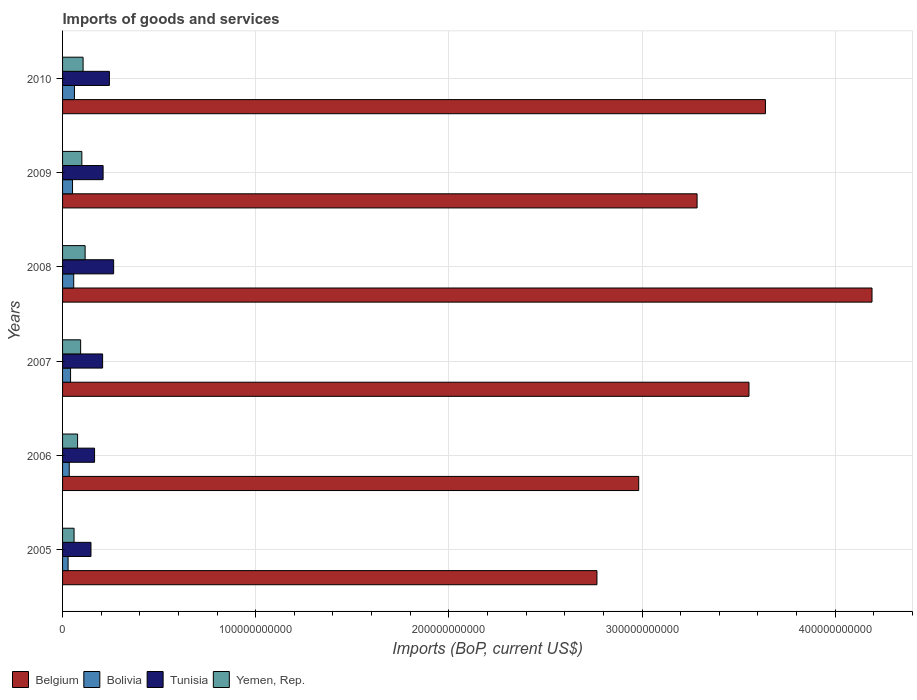How many bars are there on the 1st tick from the top?
Your response must be concise. 4. What is the label of the 3rd group of bars from the top?
Provide a short and direct response. 2008. In how many cases, is the number of bars for a given year not equal to the number of legend labels?
Your response must be concise. 0. What is the amount spent on imports in Tunisia in 2007?
Make the answer very short. 2.07e+1. Across all years, what is the maximum amount spent on imports in Tunisia?
Give a very brief answer. 2.64e+1. Across all years, what is the minimum amount spent on imports in Yemen, Rep.?
Keep it short and to the point. 5.95e+09. In which year was the amount spent on imports in Bolivia maximum?
Your response must be concise. 2010. In which year was the amount spent on imports in Bolivia minimum?
Keep it short and to the point. 2005. What is the total amount spent on imports in Belgium in the graph?
Offer a very short reply. 2.04e+12. What is the difference between the amount spent on imports in Belgium in 2005 and that in 2009?
Your answer should be compact. -5.18e+1. What is the difference between the amount spent on imports in Bolivia in 2010 and the amount spent on imports in Yemen, Rep. in 2008?
Your answer should be compact. -5.53e+09. What is the average amount spent on imports in Yemen, Rep. per year?
Provide a succinct answer. 9.23e+09. In the year 2006, what is the difference between the amount spent on imports in Bolivia and amount spent on imports in Belgium?
Make the answer very short. -2.95e+11. What is the ratio of the amount spent on imports in Yemen, Rep. in 2006 to that in 2009?
Ensure brevity in your answer.  0.78. Is the amount spent on imports in Belgium in 2007 less than that in 2010?
Your answer should be very brief. Yes. Is the difference between the amount spent on imports in Bolivia in 2008 and 2009 greater than the difference between the amount spent on imports in Belgium in 2008 and 2009?
Your answer should be very brief. No. What is the difference between the highest and the second highest amount spent on imports in Bolivia?
Your response must be concise. 3.77e+08. What is the difference between the highest and the lowest amount spent on imports in Tunisia?
Your response must be concise. 1.17e+1. Is it the case that in every year, the sum of the amount spent on imports in Yemen, Rep. and amount spent on imports in Belgium is greater than the sum of amount spent on imports in Tunisia and amount spent on imports in Bolivia?
Your answer should be compact. No. What does the 3rd bar from the bottom in 2008 represents?
Your answer should be compact. Tunisia. Is it the case that in every year, the sum of the amount spent on imports in Belgium and amount spent on imports in Tunisia is greater than the amount spent on imports in Yemen, Rep.?
Give a very brief answer. Yes. How many bars are there?
Your answer should be very brief. 24. Are all the bars in the graph horizontal?
Your answer should be compact. Yes. How many years are there in the graph?
Give a very brief answer. 6. What is the difference between two consecutive major ticks on the X-axis?
Your answer should be very brief. 1.00e+11. Are the values on the major ticks of X-axis written in scientific E-notation?
Provide a short and direct response. No. Does the graph contain any zero values?
Provide a short and direct response. No. Does the graph contain grids?
Provide a succinct answer. Yes. How are the legend labels stacked?
Your answer should be compact. Horizontal. What is the title of the graph?
Offer a terse response. Imports of goods and services. Does "Kosovo" appear as one of the legend labels in the graph?
Give a very brief answer. No. What is the label or title of the X-axis?
Offer a very short reply. Imports (BoP, current US$). What is the Imports (BoP, current US$) of Belgium in 2005?
Give a very brief answer. 2.77e+11. What is the Imports (BoP, current US$) in Bolivia in 2005?
Ensure brevity in your answer.  2.86e+09. What is the Imports (BoP, current US$) of Tunisia in 2005?
Provide a short and direct response. 1.47e+1. What is the Imports (BoP, current US$) in Yemen, Rep. in 2005?
Provide a succinct answer. 5.95e+09. What is the Imports (BoP, current US$) in Belgium in 2006?
Your answer should be very brief. 2.98e+11. What is the Imports (BoP, current US$) in Bolivia in 2006?
Offer a terse response. 3.46e+09. What is the Imports (BoP, current US$) of Tunisia in 2006?
Your response must be concise. 1.66e+1. What is the Imports (BoP, current US$) in Yemen, Rep. in 2006?
Provide a short and direct response. 7.78e+09. What is the Imports (BoP, current US$) of Belgium in 2007?
Provide a short and direct response. 3.55e+11. What is the Imports (BoP, current US$) of Bolivia in 2007?
Keep it short and to the point. 4.14e+09. What is the Imports (BoP, current US$) in Tunisia in 2007?
Ensure brevity in your answer.  2.07e+1. What is the Imports (BoP, current US$) of Yemen, Rep. in 2007?
Your answer should be compact. 9.36e+09. What is the Imports (BoP, current US$) of Belgium in 2008?
Keep it short and to the point. 4.19e+11. What is the Imports (BoP, current US$) in Bolivia in 2008?
Give a very brief answer. 5.78e+09. What is the Imports (BoP, current US$) of Tunisia in 2008?
Your answer should be compact. 2.64e+1. What is the Imports (BoP, current US$) of Yemen, Rep. in 2008?
Your response must be concise. 1.17e+1. What is the Imports (BoP, current US$) of Belgium in 2009?
Ensure brevity in your answer.  3.29e+11. What is the Imports (BoP, current US$) in Bolivia in 2009?
Offer a very short reply. 5.16e+09. What is the Imports (BoP, current US$) of Tunisia in 2009?
Provide a succinct answer. 2.10e+1. What is the Imports (BoP, current US$) of Yemen, Rep. in 2009?
Provide a succinct answer. 9.99e+09. What is the Imports (BoP, current US$) in Belgium in 2010?
Give a very brief answer. 3.64e+11. What is the Imports (BoP, current US$) in Bolivia in 2010?
Provide a succinct answer. 6.16e+09. What is the Imports (BoP, current US$) of Tunisia in 2010?
Offer a very short reply. 2.42e+1. What is the Imports (BoP, current US$) of Yemen, Rep. in 2010?
Ensure brevity in your answer.  1.06e+1. Across all years, what is the maximum Imports (BoP, current US$) of Belgium?
Provide a short and direct response. 4.19e+11. Across all years, what is the maximum Imports (BoP, current US$) of Bolivia?
Your answer should be compact. 6.16e+09. Across all years, what is the maximum Imports (BoP, current US$) in Tunisia?
Keep it short and to the point. 2.64e+1. Across all years, what is the maximum Imports (BoP, current US$) in Yemen, Rep.?
Offer a very short reply. 1.17e+1. Across all years, what is the minimum Imports (BoP, current US$) of Belgium?
Make the answer very short. 2.77e+11. Across all years, what is the minimum Imports (BoP, current US$) of Bolivia?
Ensure brevity in your answer.  2.86e+09. Across all years, what is the minimum Imports (BoP, current US$) in Tunisia?
Ensure brevity in your answer.  1.47e+1. Across all years, what is the minimum Imports (BoP, current US$) of Yemen, Rep.?
Your answer should be very brief. 5.95e+09. What is the total Imports (BoP, current US$) in Belgium in the graph?
Offer a terse response. 2.04e+12. What is the total Imports (BoP, current US$) of Bolivia in the graph?
Offer a terse response. 2.76e+1. What is the total Imports (BoP, current US$) of Tunisia in the graph?
Provide a succinct answer. 1.24e+11. What is the total Imports (BoP, current US$) in Yemen, Rep. in the graph?
Your answer should be compact. 5.54e+1. What is the difference between the Imports (BoP, current US$) of Belgium in 2005 and that in 2006?
Provide a succinct answer. -2.16e+1. What is the difference between the Imports (BoP, current US$) in Bolivia in 2005 and that in 2006?
Offer a very short reply. -5.92e+08. What is the difference between the Imports (BoP, current US$) in Tunisia in 2005 and that in 2006?
Your response must be concise. -1.86e+09. What is the difference between the Imports (BoP, current US$) of Yemen, Rep. in 2005 and that in 2006?
Offer a very short reply. -1.83e+09. What is the difference between the Imports (BoP, current US$) of Belgium in 2005 and that in 2007?
Provide a short and direct response. -7.87e+1. What is the difference between the Imports (BoP, current US$) of Bolivia in 2005 and that in 2007?
Your answer should be very brief. -1.28e+09. What is the difference between the Imports (BoP, current US$) of Tunisia in 2005 and that in 2007?
Give a very brief answer. -6.03e+09. What is the difference between the Imports (BoP, current US$) of Yemen, Rep. in 2005 and that in 2007?
Offer a very short reply. -3.40e+09. What is the difference between the Imports (BoP, current US$) in Belgium in 2005 and that in 2008?
Provide a succinct answer. -1.42e+11. What is the difference between the Imports (BoP, current US$) in Bolivia in 2005 and that in 2008?
Ensure brevity in your answer.  -2.91e+09. What is the difference between the Imports (BoP, current US$) in Tunisia in 2005 and that in 2008?
Your answer should be very brief. -1.17e+1. What is the difference between the Imports (BoP, current US$) in Yemen, Rep. in 2005 and that in 2008?
Give a very brief answer. -5.73e+09. What is the difference between the Imports (BoP, current US$) of Belgium in 2005 and that in 2009?
Make the answer very short. -5.18e+1. What is the difference between the Imports (BoP, current US$) of Bolivia in 2005 and that in 2009?
Keep it short and to the point. -2.29e+09. What is the difference between the Imports (BoP, current US$) in Tunisia in 2005 and that in 2009?
Your answer should be very brief. -6.29e+09. What is the difference between the Imports (BoP, current US$) of Yemen, Rep. in 2005 and that in 2009?
Keep it short and to the point. -4.03e+09. What is the difference between the Imports (BoP, current US$) of Belgium in 2005 and that in 2010?
Your answer should be very brief. -8.72e+1. What is the difference between the Imports (BoP, current US$) of Bolivia in 2005 and that in 2010?
Offer a terse response. -3.29e+09. What is the difference between the Imports (BoP, current US$) in Tunisia in 2005 and that in 2010?
Ensure brevity in your answer.  -9.54e+09. What is the difference between the Imports (BoP, current US$) in Yemen, Rep. in 2005 and that in 2010?
Provide a short and direct response. -4.67e+09. What is the difference between the Imports (BoP, current US$) of Belgium in 2006 and that in 2007?
Offer a terse response. -5.71e+1. What is the difference between the Imports (BoP, current US$) in Bolivia in 2006 and that in 2007?
Keep it short and to the point. -6.83e+08. What is the difference between the Imports (BoP, current US$) of Tunisia in 2006 and that in 2007?
Give a very brief answer. -4.17e+09. What is the difference between the Imports (BoP, current US$) of Yemen, Rep. in 2006 and that in 2007?
Make the answer very short. -1.58e+09. What is the difference between the Imports (BoP, current US$) in Belgium in 2006 and that in 2008?
Your response must be concise. -1.21e+11. What is the difference between the Imports (BoP, current US$) of Bolivia in 2006 and that in 2008?
Make the answer very short. -2.32e+09. What is the difference between the Imports (BoP, current US$) in Tunisia in 2006 and that in 2008?
Provide a short and direct response. -9.88e+09. What is the difference between the Imports (BoP, current US$) of Yemen, Rep. in 2006 and that in 2008?
Give a very brief answer. -3.90e+09. What is the difference between the Imports (BoP, current US$) in Belgium in 2006 and that in 2009?
Provide a short and direct response. -3.02e+1. What is the difference between the Imports (BoP, current US$) of Bolivia in 2006 and that in 2009?
Make the answer very short. -1.70e+09. What is the difference between the Imports (BoP, current US$) in Tunisia in 2006 and that in 2009?
Make the answer very short. -4.43e+09. What is the difference between the Imports (BoP, current US$) of Yemen, Rep. in 2006 and that in 2009?
Provide a succinct answer. -2.21e+09. What is the difference between the Imports (BoP, current US$) in Belgium in 2006 and that in 2010?
Your answer should be very brief. -6.56e+1. What is the difference between the Imports (BoP, current US$) in Bolivia in 2006 and that in 2010?
Offer a terse response. -2.70e+09. What is the difference between the Imports (BoP, current US$) in Tunisia in 2006 and that in 2010?
Your answer should be compact. -7.68e+09. What is the difference between the Imports (BoP, current US$) of Yemen, Rep. in 2006 and that in 2010?
Your answer should be compact. -2.85e+09. What is the difference between the Imports (BoP, current US$) of Belgium in 2007 and that in 2008?
Offer a very short reply. -6.37e+1. What is the difference between the Imports (BoP, current US$) in Bolivia in 2007 and that in 2008?
Keep it short and to the point. -1.64e+09. What is the difference between the Imports (BoP, current US$) of Tunisia in 2007 and that in 2008?
Your answer should be very brief. -5.71e+09. What is the difference between the Imports (BoP, current US$) of Yemen, Rep. in 2007 and that in 2008?
Offer a very short reply. -2.32e+09. What is the difference between the Imports (BoP, current US$) in Belgium in 2007 and that in 2009?
Offer a terse response. 2.69e+1. What is the difference between the Imports (BoP, current US$) in Bolivia in 2007 and that in 2009?
Ensure brevity in your answer.  -1.02e+09. What is the difference between the Imports (BoP, current US$) of Tunisia in 2007 and that in 2009?
Make the answer very short. -2.56e+08. What is the difference between the Imports (BoP, current US$) in Yemen, Rep. in 2007 and that in 2009?
Your response must be concise. -6.31e+08. What is the difference between the Imports (BoP, current US$) of Belgium in 2007 and that in 2010?
Offer a very short reply. -8.51e+09. What is the difference between the Imports (BoP, current US$) of Bolivia in 2007 and that in 2010?
Your answer should be compact. -2.02e+09. What is the difference between the Imports (BoP, current US$) in Tunisia in 2007 and that in 2010?
Make the answer very short. -3.51e+09. What is the difference between the Imports (BoP, current US$) of Yemen, Rep. in 2007 and that in 2010?
Provide a short and direct response. -1.27e+09. What is the difference between the Imports (BoP, current US$) of Belgium in 2008 and that in 2009?
Ensure brevity in your answer.  9.06e+1. What is the difference between the Imports (BoP, current US$) in Bolivia in 2008 and that in 2009?
Provide a succinct answer. 6.22e+08. What is the difference between the Imports (BoP, current US$) of Tunisia in 2008 and that in 2009?
Make the answer very short. 5.46e+09. What is the difference between the Imports (BoP, current US$) of Yemen, Rep. in 2008 and that in 2009?
Your answer should be very brief. 1.69e+09. What is the difference between the Imports (BoP, current US$) in Belgium in 2008 and that in 2010?
Your answer should be very brief. 5.52e+1. What is the difference between the Imports (BoP, current US$) of Bolivia in 2008 and that in 2010?
Make the answer very short. -3.77e+08. What is the difference between the Imports (BoP, current US$) in Tunisia in 2008 and that in 2010?
Provide a succinct answer. 2.21e+09. What is the difference between the Imports (BoP, current US$) of Yemen, Rep. in 2008 and that in 2010?
Provide a succinct answer. 1.05e+09. What is the difference between the Imports (BoP, current US$) in Belgium in 2009 and that in 2010?
Provide a succinct answer. -3.54e+1. What is the difference between the Imports (BoP, current US$) in Bolivia in 2009 and that in 2010?
Make the answer very short. -1.00e+09. What is the difference between the Imports (BoP, current US$) of Tunisia in 2009 and that in 2010?
Offer a terse response. -3.25e+09. What is the difference between the Imports (BoP, current US$) in Yemen, Rep. in 2009 and that in 2010?
Ensure brevity in your answer.  -6.41e+08. What is the difference between the Imports (BoP, current US$) in Belgium in 2005 and the Imports (BoP, current US$) in Bolivia in 2006?
Offer a very short reply. 2.73e+11. What is the difference between the Imports (BoP, current US$) of Belgium in 2005 and the Imports (BoP, current US$) of Tunisia in 2006?
Your response must be concise. 2.60e+11. What is the difference between the Imports (BoP, current US$) of Belgium in 2005 and the Imports (BoP, current US$) of Yemen, Rep. in 2006?
Provide a succinct answer. 2.69e+11. What is the difference between the Imports (BoP, current US$) in Bolivia in 2005 and the Imports (BoP, current US$) in Tunisia in 2006?
Give a very brief answer. -1.37e+1. What is the difference between the Imports (BoP, current US$) in Bolivia in 2005 and the Imports (BoP, current US$) in Yemen, Rep. in 2006?
Your answer should be very brief. -4.92e+09. What is the difference between the Imports (BoP, current US$) of Tunisia in 2005 and the Imports (BoP, current US$) of Yemen, Rep. in 2006?
Your response must be concise. 6.92e+09. What is the difference between the Imports (BoP, current US$) of Belgium in 2005 and the Imports (BoP, current US$) of Bolivia in 2007?
Give a very brief answer. 2.73e+11. What is the difference between the Imports (BoP, current US$) of Belgium in 2005 and the Imports (BoP, current US$) of Tunisia in 2007?
Give a very brief answer. 2.56e+11. What is the difference between the Imports (BoP, current US$) in Belgium in 2005 and the Imports (BoP, current US$) in Yemen, Rep. in 2007?
Ensure brevity in your answer.  2.67e+11. What is the difference between the Imports (BoP, current US$) of Bolivia in 2005 and the Imports (BoP, current US$) of Tunisia in 2007?
Your response must be concise. -1.79e+1. What is the difference between the Imports (BoP, current US$) of Bolivia in 2005 and the Imports (BoP, current US$) of Yemen, Rep. in 2007?
Offer a very short reply. -6.49e+09. What is the difference between the Imports (BoP, current US$) of Tunisia in 2005 and the Imports (BoP, current US$) of Yemen, Rep. in 2007?
Your response must be concise. 5.34e+09. What is the difference between the Imports (BoP, current US$) of Belgium in 2005 and the Imports (BoP, current US$) of Bolivia in 2008?
Your response must be concise. 2.71e+11. What is the difference between the Imports (BoP, current US$) in Belgium in 2005 and the Imports (BoP, current US$) in Tunisia in 2008?
Your answer should be compact. 2.50e+11. What is the difference between the Imports (BoP, current US$) of Belgium in 2005 and the Imports (BoP, current US$) of Yemen, Rep. in 2008?
Provide a short and direct response. 2.65e+11. What is the difference between the Imports (BoP, current US$) of Bolivia in 2005 and the Imports (BoP, current US$) of Tunisia in 2008?
Make the answer very short. -2.36e+1. What is the difference between the Imports (BoP, current US$) of Bolivia in 2005 and the Imports (BoP, current US$) of Yemen, Rep. in 2008?
Ensure brevity in your answer.  -8.82e+09. What is the difference between the Imports (BoP, current US$) in Tunisia in 2005 and the Imports (BoP, current US$) in Yemen, Rep. in 2008?
Keep it short and to the point. 3.02e+09. What is the difference between the Imports (BoP, current US$) in Belgium in 2005 and the Imports (BoP, current US$) in Bolivia in 2009?
Provide a short and direct response. 2.72e+11. What is the difference between the Imports (BoP, current US$) of Belgium in 2005 and the Imports (BoP, current US$) of Tunisia in 2009?
Keep it short and to the point. 2.56e+11. What is the difference between the Imports (BoP, current US$) in Belgium in 2005 and the Imports (BoP, current US$) in Yemen, Rep. in 2009?
Give a very brief answer. 2.67e+11. What is the difference between the Imports (BoP, current US$) in Bolivia in 2005 and the Imports (BoP, current US$) in Tunisia in 2009?
Give a very brief answer. -1.81e+1. What is the difference between the Imports (BoP, current US$) of Bolivia in 2005 and the Imports (BoP, current US$) of Yemen, Rep. in 2009?
Your response must be concise. -7.12e+09. What is the difference between the Imports (BoP, current US$) of Tunisia in 2005 and the Imports (BoP, current US$) of Yemen, Rep. in 2009?
Your answer should be compact. 4.71e+09. What is the difference between the Imports (BoP, current US$) in Belgium in 2005 and the Imports (BoP, current US$) in Bolivia in 2010?
Offer a terse response. 2.71e+11. What is the difference between the Imports (BoP, current US$) of Belgium in 2005 and the Imports (BoP, current US$) of Tunisia in 2010?
Provide a succinct answer. 2.52e+11. What is the difference between the Imports (BoP, current US$) of Belgium in 2005 and the Imports (BoP, current US$) of Yemen, Rep. in 2010?
Offer a terse response. 2.66e+11. What is the difference between the Imports (BoP, current US$) in Bolivia in 2005 and the Imports (BoP, current US$) in Tunisia in 2010?
Keep it short and to the point. -2.14e+1. What is the difference between the Imports (BoP, current US$) in Bolivia in 2005 and the Imports (BoP, current US$) in Yemen, Rep. in 2010?
Provide a short and direct response. -7.76e+09. What is the difference between the Imports (BoP, current US$) in Tunisia in 2005 and the Imports (BoP, current US$) in Yemen, Rep. in 2010?
Keep it short and to the point. 4.07e+09. What is the difference between the Imports (BoP, current US$) of Belgium in 2006 and the Imports (BoP, current US$) of Bolivia in 2007?
Your response must be concise. 2.94e+11. What is the difference between the Imports (BoP, current US$) in Belgium in 2006 and the Imports (BoP, current US$) in Tunisia in 2007?
Give a very brief answer. 2.78e+11. What is the difference between the Imports (BoP, current US$) of Belgium in 2006 and the Imports (BoP, current US$) of Yemen, Rep. in 2007?
Offer a terse response. 2.89e+11. What is the difference between the Imports (BoP, current US$) in Bolivia in 2006 and the Imports (BoP, current US$) in Tunisia in 2007?
Ensure brevity in your answer.  -1.73e+1. What is the difference between the Imports (BoP, current US$) in Bolivia in 2006 and the Imports (BoP, current US$) in Yemen, Rep. in 2007?
Offer a very short reply. -5.90e+09. What is the difference between the Imports (BoP, current US$) of Tunisia in 2006 and the Imports (BoP, current US$) of Yemen, Rep. in 2007?
Your answer should be very brief. 7.21e+09. What is the difference between the Imports (BoP, current US$) in Belgium in 2006 and the Imports (BoP, current US$) in Bolivia in 2008?
Give a very brief answer. 2.93e+11. What is the difference between the Imports (BoP, current US$) in Belgium in 2006 and the Imports (BoP, current US$) in Tunisia in 2008?
Provide a short and direct response. 2.72e+11. What is the difference between the Imports (BoP, current US$) in Belgium in 2006 and the Imports (BoP, current US$) in Yemen, Rep. in 2008?
Ensure brevity in your answer.  2.87e+11. What is the difference between the Imports (BoP, current US$) in Bolivia in 2006 and the Imports (BoP, current US$) in Tunisia in 2008?
Your answer should be very brief. -2.30e+1. What is the difference between the Imports (BoP, current US$) in Bolivia in 2006 and the Imports (BoP, current US$) in Yemen, Rep. in 2008?
Your response must be concise. -8.22e+09. What is the difference between the Imports (BoP, current US$) in Tunisia in 2006 and the Imports (BoP, current US$) in Yemen, Rep. in 2008?
Your response must be concise. 4.88e+09. What is the difference between the Imports (BoP, current US$) of Belgium in 2006 and the Imports (BoP, current US$) of Bolivia in 2009?
Your response must be concise. 2.93e+11. What is the difference between the Imports (BoP, current US$) in Belgium in 2006 and the Imports (BoP, current US$) in Tunisia in 2009?
Your response must be concise. 2.77e+11. What is the difference between the Imports (BoP, current US$) of Belgium in 2006 and the Imports (BoP, current US$) of Yemen, Rep. in 2009?
Your answer should be compact. 2.88e+11. What is the difference between the Imports (BoP, current US$) of Bolivia in 2006 and the Imports (BoP, current US$) of Tunisia in 2009?
Offer a terse response. -1.75e+1. What is the difference between the Imports (BoP, current US$) of Bolivia in 2006 and the Imports (BoP, current US$) of Yemen, Rep. in 2009?
Ensure brevity in your answer.  -6.53e+09. What is the difference between the Imports (BoP, current US$) of Tunisia in 2006 and the Imports (BoP, current US$) of Yemen, Rep. in 2009?
Keep it short and to the point. 6.58e+09. What is the difference between the Imports (BoP, current US$) of Belgium in 2006 and the Imports (BoP, current US$) of Bolivia in 2010?
Offer a very short reply. 2.92e+11. What is the difference between the Imports (BoP, current US$) in Belgium in 2006 and the Imports (BoP, current US$) in Tunisia in 2010?
Provide a succinct answer. 2.74e+11. What is the difference between the Imports (BoP, current US$) in Belgium in 2006 and the Imports (BoP, current US$) in Yemen, Rep. in 2010?
Your response must be concise. 2.88e+11. What is the difference between the Imports (BoP, current US$) of Bolivia in 2006 and the Imports (BoP, current US$) of Tunisia in 2010?
Your answer should be very brief. -2.08e+1. What is the difference between the Imports (BoP, current US$) in Bolivia in 2006 and the Imports (BoP, current US$) in Yemen, Rep. in 2010?
Your response must be concise. -7.17e+09. What is the difference between the Imports (BoP, current US$) in Tunisia in 2006 and the Imports (BoP, current US$) in Yemen, Rep. in 2010?
Give a very brief answer. 5.93e+09. What is the difference between the Imports (BoP, current US$) of Belgium in 2007 and the Imports (BoP, current US$) of Bolivia in 2008?
Keep it short and to the point. 3.50e+11. What is the difference between the Imports (BoP, current US$) in Belgium in 2007 and the Imports (BoP, current US$) in Tunisia in 2008?
Your answer should be compact. 3.29e+11. What is the difference between the Imports (BoP, current US$) in Belgium in 2007 and the Imports (BoP, current US$) in Yemen, Rep. in 2008?
Give a very brief answer. 3.44e+11. What is the difference between the Imports (BoP, current US$) in Bolivia in 2007 and the Imports (BoP, current US$) in Tunisia in 2008?
Offer a terse response. -2.23e+1. What is the difference between the Imports (BoP, current US$) in Bolivia in 2007 and the Imports (BoP, current US$) in Yemen, Rep. in 2008?
Your answer should be compact. -7.54e+09. What is the difference between the Imports (BoP, current US$) in Tunisia in 2007 and the Imports (BoP, current US$) in Yemen, Rep. in 2008?
Ensure brevity in your answer.  9.05e+09. What is the difference between the Imports (BoP, current US$) of Belgium in 2007 and the Imports (BoP, current US$) of Bolivia in 2009?
Ensure brevity in your answer.  3.50e+11. What is the difference between the Imports (BoP, current US$) in Belgium in 2007 and the Imports (BoP, current US$) in Tunisia in 2009?
Provide a short and direct response. 3.34e+11. What is the difference between the Imports (BoP, current US$) in Belgium in 2007 and the Imports (BoP, current US$) in Yemen, Rep. in 2009?
Make the answer very short. 3.45e+11. What is the difference between the Imports (BoP, current US$) in Bolivia in 2007 and the Imports (BoP, current US$) in Tunisia in 2009?
Your response must be concise. -1.68e+1. What is the difference between the Imports (BoP, current US$) in Bolivia in 2007 and the Imports (BoP, current US$) in Yemen, Rep. in 2009?
Offer a terse response. -5.85e+09. What is the difference between the Imports (BoP, current US$) of Tunisia in 2007 and the Imports (BoP, current US$) of Yemen, Rep. in 2009?
Your answer should be compact. 1.07e+1. What is the difference between the Imports (BoP, current US$) in Belgium in 2007 and the Imports (BoP, current US$) in Bolivia in 2010?
Give a very brief answer. 3.49e+11. What is the difference between the Imports (BoP, current US$) in Belgium in 2007 and the Imports (BoP, current US$) in Tunisia in 2010?
Offer a very short reply. 3.31e+11. What is the difference between the Imports (BoP, current US$) of Belgium in 2007 and the Imports (BoP, current US$) of Yemen, Rep. in 2010?
Provide a short and direct response. 3.45e+11. What is the difference between the Imports (BoP, current US$) of Bolivia in 2007 and the Imports (BoP, current US$) of Tunisia in 2010?
Make the answer very short. -2.01e+1. What is the difference between the Imports (BoP, current US$) of Bolivia in 2007 and the Imports (BoP, current US$) of Yemen, Rep. in 2010?
Make the answer very short. -6.49e+09. What is the difference between the Imports (BoP, current US$) of Tunisia in 2007 and the Imports (BoP, current US$) of Yemen, Rep. in 2010?
Provide a short and direct response. 1.01e+1. What is the difference between the Imports (BoP, current US$) in Belgium in 2008 and the Imports (BoP, current US$) in Bolivia in 2009?
Offer a terse response. 4.14e+11. What is the difference between the Imports (BoP, current US$) of Belgium in 2008 and the Imports (BoP, current US$) of Tunisia in 2009?
Ensure brevity in your answer.  3.98e+11. What is the difference between the Imports (BoP, current US$) of Belgium in 2008 and the Imports (BoP, current US$) of Yemen, Rep. in 2009?
Provide a succinct answer. 4.09e+11. What is the difference between the Imports (BoP, current US$) in Bolivia in 2008 and the Imports (BoP, current US$) in Tunisia in 2009?
Provide a succinct answer. -1.52e+1. What is the difference between the Imports (BoP, current US$) of Bolivia in 2008 and the Imports (BoP, current US$) of Yemen, Rep. in 2009?
Make the answer very short. -4.21e+09. What is the difference between the Imports (BoP, current US$) of Tunisia in 2008 and the Imports (BoP, current US$) of Yemen, Rep. in 2009?
Your answer should be compact. 1.65e+1. What is the difference between the Imports (BoP, current US$) of Belgium in 2008 and the Imports (BoP, current US$) of Bolivia in 2010?
Offer a terse response. 4.13e+11. What is the difference between the Imports (BoP, current US$) of Belgium in 2008 and the Imports (BoP, current US$) of Tunisia in 2010?
Your response must be concise. 3.95e+11. What is the difference between the Imports (BoP, current US$) in Belgium in 2008 and the Imports (BoP, current US$) in Yemen, Rep. in 2010?
Make the answer very short. 4.08e+11. What is the difference between the Imports (BoP, current US$) of Bolivia in 2008 and the Imports (BoP, current US$) of Tunisia in 2010?
Keep it short and to the point. -1.85e+1. What is the difference between the Imports (BoP, current US$) of Bolivia in 2008 and the Imports (BoP, current US$) of Yemen, Rep. in 2010?
Keep it short and to the point. -4.85e+09. What is the difference between the Imports (BoP, current US$) in Tunisia in 2008 and the Imports (BoP, current US$) in Yemen, Rep. in 2010?
Provide a short and direct response. 1.58e+1. What is the difference between the Imports (BoP, current US$) in Belgium in 2009 and the Imports (BoP, current US$) in Bolivia in 2010?
Keep it short and to the point. 3.22e+11. What is the difference between the Imports (BoP, current US$) of Belgium in 2009 and the Imports (BoP, current US$) of Tunisia in 2010?
Offer a very short reply. 3.04e+11. What is the difference between the Imports (BoP, current US$) of Belgium in 2009 and the Imports (BoP, current US$) of Yemen, Rep. in 2010?
Ensure brevity in your answer.  3.18e+11. What is the difference between the Imports (BoP, current US$) in Bolivia in 2009 and the Imports (BoP, current US$) in Tunisia in 2010?
Make the answer very short. -1.91e+1. What is the difference between the Imports (BoP, current US$) of Bolivia in 2009 and the Imports (BoP, current US$) of Yemen, Rep. in 2010?
Offer a terse response. -5.47e+09. What is the difference between the Imports (BoP, current US$) in Tunisia in 2009 and the Imports (BoP, current US$) in Yemen, Rep. in 2010?
Your response must be concise. 1.04e+1. What is the average Imports (BoP, current US$) in Belgium per year?
Keep it short and to the point. 3.40e+11. What is the average Imports (BoP, current US$) in Bolivia per year?
Your answer should be compact. 4.59e+09. What is the average Imports (BoP, current US$) in Tunisia per year?
Make the answer very short. 2.06e+1. What is the average Imports (BoP, current US$) in Yemen, Rep. per year?
Keep it short and to the point. 9.23e+09. In the year 2005, what is the difference between the Imports (BoP, current US$) of Belgium and Imports (BoP, current US$) of Bolivia?
Offer a terse response. 2.74e+11. In the year 2005, what is the difference between the Imports (BoP, current US$) of Belgium and Imports (BoP, current US$) of Tunisia?
Your answer should be compact. 2.62e+11. In the year 2005, what is the difference between the Imports (BoP, current US$) in Belgium and Imports (BoP, current US$) in Yemen, Rep.?
Your response must be concise. 2.71e+11. In the year 2005, what is the difference between the Imports (BoP, current US$) of Bolivia and Imports (BoP, current US$) of Tunisia?
Your answer should be very brief. -1.18e+1. In the year 2005, what is the difference between the Imports (BoP, current US$) of Bolivia and Imports (BoP, current US$) of Yemen, Rep.?
Provide a succinct answer. -3.09e+09. In the year 2005, what is the difference between the Imports (BoP, current US$) in Tunisia and Imports (BoP, current US$) in Yemen, Rep.?
Make the answer very short. 8.75e+09. In the year 2006, what is the difference between the Imports (BoP, current US$) of Belgium and Imports (BoP, current US$) of Bolivia?
Ensure brevity in your answer.  2.95e+11. In the year 2006, what is the difference between the Imports (BoP, current US$) in Belgium and Imports (BoP, current US$) in Tunisia?
Your answer should be very brief. 2.82e+11. In the year 2006, what is the difference between the Imports (BoP, current US$) in Belgium and Imports (BoP, current US$) in Yemen, Rep.?
Your answer should be compact. 2.91e+11. In the year 2006, what is the difference between the Imports (BoP, current US$) in Bolivia and Imports (BoP, current US$) in Tunisia?
Offer a terse response. -1.31e+1. In the year 2006, what is the difference between the Imports (BoP, current US$) in Bolivia and Imports (BoP, current US$) in Yemen, Rep.?
Your answer should be compact. -4.32e+09. In the year 2006, what is the difference between the Imports (BoP, current US$) of Tunisia and Imports (BoP, current US$) of Yemen, Rep.?
Provide a short and direct response. 8.78e+09. In the year 2007, what is the difference between the Imports (BoP, current US$) of Belgium and Imports (BoP, current US$) of Bolivia?
Keep it short and to the point. 3.51e+11. In the year 2007, what is the difference between the Imports (BoP, current US$) of Belgium and Imports (BoP, current US$) of Tunisia?
Make the answer very short. 3.35e+11. In the year 2007, what is the difference between the Imports (BoP, current US$) in Belgium and Imports (BoP, current US$) in Yemen, Rep.?
Make the answer very short. 3.46e+11. In the year 2007, what is the difference between the Imports (BoP, current US$) of Bolivia and Imports (BoP, current US$) of Tunisia?
Your answer should be very brief. -1.66e+1. In the year 2007, what is the difference between the Imports (BoP, current US$) of Bolivia and Imports (BoP, current US$) of Yemen, Rep.?
Your answer should be compact. -5.22e+09. In the year 2007, what is the difference between the Imports (BoP, current US$) of Tunisia and Imports (BoP, current US$) of Yemen, Rep.?
Offer a terse response. 1.14e+1. In the year 2008, what is the difference between the Imports (BoP, current US$) of Belgium and Imports (BoP, current US$) of Bolivia?
Ensure brevity in your answer.  4.13e+11. In the year 2008, what is the difference between the Imports (BoP, current US$) in Belgium and Imports (BoP, current US$) in Tunisia?
Your answer should be very brief. 3.93e+11. In the year 2008, what is the difference between the Imports (BoP, current US$) in Belgium and Imports (BoP, current US$) in Yemen, Rep.?
Keep it short and to the point. 4.07e+11. In the year 2008, what is the difference between the Imports (BoP, current US$) of Bolivia and Imports (BoP, current US$) of Tunisia?
Your response must be concise. -2.07e+1. In the year 2008, what is the difference between the Imports (BoP, current US$) in Bolivia and Imports (BoP, current US$) in Yemen, Rep.?
Offer a terse response. -5.90e+09. In the year 2008, what is the difference between the Imports (BoP, current US$) in Tunisia and Imports (BoP, current US$) in Yemen, Rep.?
Make the answer very short. 1.48e+1. In the year 2009, what is the difference between the Imports (BoP, current US$) of Belgium and Imports (BoP, current US$) of Bolivia?
Your answer should be compact. 3.23e+11. In the year 2009, what is the difference between the Imports (BoP, current US$) in Belgium and Imports (BoP, current US$) in Tunisia?
Provide a succinct answer. 3.08e+11. In the year 2009, what is the difference between the Imports (BoP, current US$) of Belgium and Imports (BoP, current US$) of Yemen, Rep.?
Your answer should be compact. 3.19e+11. In the year 2009, what is the difference between the Imports (BoP, current US$) of Bolivia and Imports (BoP, current US$) of Tunisia?
Your answer should be very brief. -1.58e+1. In the year 2009, what is the difference between the Imports (BoP, current US$) of Bolivia and Imports (BoP, current US$) of Yemen, Rep.?
Ensure brevity in your answer.  -4.83e+09. In the year 2009, what is the difference between the Imports (BoP, current US$) of Tunisia and Imports (BoP, current US$) of Yemen, Rep.?
Your response must be concise. 1.10e+1. In the year 2010, what is the difference between the Imports (BoP, current US$) of Belgium and Imports (BoP, current US$) of Bolivia?
Offer a terse response. 3.58e+11. In the year 2010, what is the difference between the Imports (BoP, current US$) of Belgium and Imports (BoP, current US$) of Tunisia?
Offer a very short reply. 3.40e+11. In the year 2010, what is the difference between the Imports (BoP, current US$) in Belgium and Imports (BoP, current US$) in Yemen, Rep.?
Your answer should be very brief. 3.53e+11. In the year 2010, what is the difference between the Imports (BoP, current US$) of Bolivia and Imports (BoP, current US$) of Tunisia?
Your answer should be very brief. -1.81e+1. In the year 2010, what is the difference between the Imports (BoP, current US$) of Bolivia and Imports (BoP, current US$) of Yemen, Rep.?
Keep it short and to the point. -4.47e+09. In the year 2010, what is the difference between the Imports (BoP, current US$) of Tunisia and Imports (BoP, current US$) of Yemen, Rep.?
Your response must be concise. 1.36e+1. What is the ratio of the Imports (BoP, current US$) of Belgium in 2005 to that in 2006?
Your answer should be very brief. 0.93. What is the ratio of the Imports (BoP, current US$) of Bolivia in 2005 to that in 2006?
Offer a very short reply. 0.83. What is the ratio of the Imports (BoP, current US$) of Tunisia in 2005 to that in 2006?
Offer a very short reply. 0.89. What is the ratio of the Imports (BoP, current US$) of Yemen, Rep. in 2005 to that in 2006?
Offer a very short reply. 0.77. What is the ratio of the Imports (BoP, current US$) in Belgium in 2005 to that in 2007?
Offer a very short reply. 0.78. What is the ratio of the Imports (BoP, current US$) in Bolivia in 2005 to that in 2007?
Your response must be concise. 0.69. What is the ratio of the Imports (BoP, current US$) of Tunisia in 2005 to that in 2007?
Keep it short and to the point. 0.71. What is the ratio of the Imports (BoP, current US$) in Yemen, Rep. in 2005 to that in 2007?
Your answer should be compact. 0.64. What is the ratio of the Imports (BoP, current US$) of Belgium in 2005 to that in 2008?
Your answer should be very brief. 0.66. What is the ratio of the Imports (BoP, current US$) of Bolivia in 2005 to that in 2008?
Your answer should be compact. 0.5. What is the ratio of the Imports (BoP, current US$) of Tunisia in 2005 to that in 2008?
Keep it short and to the point. 0.56. What is the ratio of the Imports (BoP, current US$) of Yemen, Rep. in 2005 to that in 2008?
Offer a very short reply. 0.51. What is the ratio of the Imports (BoP, current US$) in Belgium in 2005 to that in 2009?
Offer a terse response. 0.84. What is the ratio of the Imports (BoP, current US$) of Bolivia in 2005 to that in 2009?
Keep it short and to the point. 0.56. What is the ratio of the Imports (BoP, current US$) in Tunisia in 2005 to that in 2009?
Keep it short and to the point. 0.7. What is the ratio of the Imports (BoP, current US$) in Yemen, Rep. in 2005 to that in 2009?
Your answer should be compact. 0.6. What is the ratio of the Imports (BoP, current US$) of Belgium in 2005 to that in 2010?
Ensure brevity in your answer.  0.76. What is the ratio of the Imports (BoP, current US$) of Bolivia in 2005 to that in 2010?
Keep it short and to the point. 0.47. What is the ratio of the Imports (BoP, current US$) of Tunisia in 2005 to that in 2010?
Give a very brief answer. 0.61. What is the ratio of the Imports (BoP, current US$) of Yemen, Rep. in 2005 to that in 2010?
Provide a succinct answer. 0.56. What is the ratio of the Imports (BoP, current US$) of Belgium in 2006 to that in 2007?
Offer a terse response. 0.84. What is the ratio of the Imports (BoP, current US$) in Bolivia in 2006 to that in 2007?
Give a very brief answer. 0.83. What is the ratio of the Imports (BoP, current US$) of Tunisia in 2006 to that in 2007?
Offer a terse response. 0.8. What is the ratio of the Imports (BoP, current US$) of Yemen, Rep. in 2006 to that in 2007?
Keep it short and to the point. 0.83. What is the ratio of the Imports (BoP, current US$) of Belgium in 2006 to that in 2008?
Give a very brief answer. 0.71. What is the ratio of the Imports (BoP, current US$) in Bolivia in 2006 to that in 2008?
Keep it short and to the point. 0.6. What is the ratio of the Imports (BoP, current US$) in Tunisia in 2006 to that in 2008?
Make the answer very short. 0.63. What is the ratio of the Imports (BoP, current US$) of Yemen, Rep. in 2006 to that in 2008?
Ensure brevity in your answer.  0.67. What is the ratio of the Imports (BoP, current US$) of Belgium in 2006 to that in 2009?
Offer a very short reply. 0.91. What is the ratio of the Imports (BoP, current US$) in Bolivia in 2006 to that in 2009?
Keep it short and to the point. 0.67. What is the ratio of the Imports (BoP, current US$) in Tunisia in 2006 to that in 2009?
Your response must be concise. 0.79. What is the ratio of the Imports (BoP, current US$) in Yemen, Rep. in 2006 to that in 2009?
Make the answer very short. 0.78. What is the ratio of the Imports (BoP, current US$) of Belgium in 2006 to that in 2010?
Keep it short and to the point. 0.82. What is the ratio of the Imports (BoP, current US$) in Bolivia in 2006 to that in 2010?
Your answer should be very brief. 0.56. What is the ratio of the Imports (BoP, current US$) in Tunisia in 2006 to that in 2010?
Provide a succinct answer. 0.68. What is the ratio of the Imports (BoP, current US$) of Yemen, Rep. in 2006 to that in 2010?
Provide a short and direct response. 0.73. What is the ratio of the Imports (BoP, current US$) in Belgium in 2007 to that in 2008?
Your answer should be very brief. 0.85. What is the ratio of the Imports (BoP, current US$) of Bolivia in 2007 to that in 2008?
Your response must be concise. 0.72. What is the ratio of the Imports (BoP, current US$) in Tunisia in 2007 to that in 2008?
Your answer should be very brief. 0.78. What is the ratio of the Imports (BoP, current US$) of Yemen, Rep. in 2007 to that in 2008?
Your response must be concise. 0.8. What is the ratio of the Imports (BoP, current US$) in Belgium in 2007 to that in 2009?
Your answer should be compact. 1.08. What is the ratio of the Imports (BoP, current US$) in Bolivia in 2007 to that in 2009?
Offer a terse response. 0.8. What is the ratio of the Imports (BoP, current US$) of Yemen, Rep. in 2007 to that in 2009?
Your response must be concise. 0.94. What is the ratio of the Imports (BoP, current US$) of Belgium in 2007 to that in 2010?
Make the answer very short. 0.98. What is the ratio of the Imports (BoP, current US$) of Bolivia in 2007 to that in 2010?
Your answer should be very brief. 0.67. What is the ratio of the Imports (BoP, current US$) in Tunisia in 2007 to that in 2010?
Provide a succinct answer. 0.86. What is the ratio of the Imports (BoP, current US$) of Yemen, Rep. in 2007 to that in 2010?
Your answer should be very brief. 0.88. What is the ratio of the Imports (BoP, current US$) of Belgium in 2008 to that in 2009?
Give a very brief answer. 1.28. What is the ratio of the Imports (BoP, current US$) of Bolivia in 2008 to that in 2009?
Give a very brief answer. 1.12. What is the ratio of the Imports (BoP, current US$) in Tunisia in 2008 to that in 2009?
Make the answer very short. 1.26. What is the ratio of the Imports (BoP, current US$) of Yemen, Rep. in 2008 to that in 2009?
Keep it short and to the point. 1.17. What is the ratio of the Imports (BoP, current US$) of Belgium in 2008 to that in 2010?
Your answer should be very brief. 1.15. What is the ratio of the Imports (BoP, current US$) of Bolivia in 2008 to that in 2010?
Provide a succinct answer. 0.94. What is the ratio of the Imports (BoP, current US$) of Tunisia in 2008 to that in 2010?
Make the answer very short. 1.09. What is the ratio of the Imports (BoP, current US$) in Yemen, Rep. in 2008 to that in 2010?
Provide a succinct answer. 1.1. What is the ratio of the Imports (BoP, current US$) in Belgium in 2009 to that in 2010?
Ensure brevity in your answer.  0.9. What is the ratio of the Imports (BoP, current US$) of Bolivia in 2009 to that in 2010?
Offer a terse response. 0.84. What is the ratio of the Imports (BoP, current US$) in Tunisia in 2009 to that in 2010?
Your answer should be compact. 0.87. What is the ratio of the Imports (BoP, current US$) of Yemen, Rep. in 2009 to that in 2010?
Provide a short and direct response. 0.94. What is the difference between the highest and the second highest Imports (BoP, current US$) of Belgium?
Make the answer very short. 5.52e+1. What is the difference between the highest and the second highest Imports (BoP, current US$) in Bolivia?
Offer a terse response. 3.77e+08. What is the difference between the highest and the second highest Imports (BoP, current US$) in Tunisia?
Provide a short and direct response. 2.21e+09. What is the difference between the highest and the second highest Imports (BoP, current US$) of Yemen, Rep.?
Your answer should be compact. 1.05e+09. What is the difference between the highest and the lowest Imports (BoP, current US$) in Belgium?
Offer a terse response. 1.42e+11. What is the difference between the highest and the lowest Imports (BoP, current US$) in Bolivia?
Provide a short and direct response. 3.29e+09. What is the difference between the highest and the lowest Imports (BoP, current US$) in Tunisia?
Your response must be concise. 1.17e+1. What is the difference between the highest and the lowest Imports (BoP, current US$) in Yemen, Rep.?
Your response must be concise. 5.73e+09. 